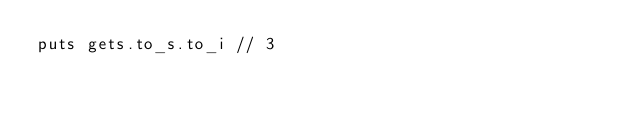<code> <loc_0><loc_0><loc_500><loc_500><_Crystal_>puts gets.to_s.to_i // 3</code> 